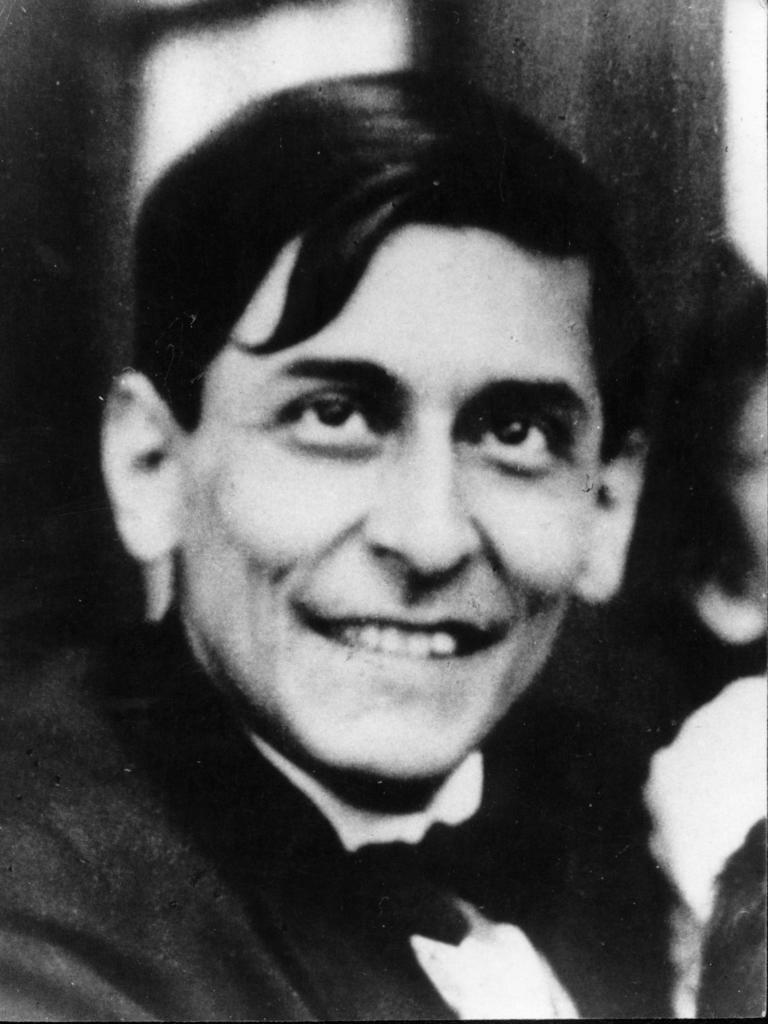In one or two sentences, can you explain what this image depicts? This is a black and white image and in this picture we can see a man smiling. 